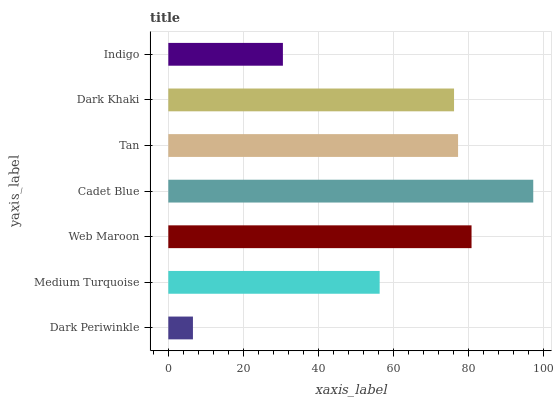Is Dark Periwinkle the minimum?
Answer yes or no. Yes. Is Cadet Blue the maximum?
Answer yes or no. Yes. Is Medium Turquoise the minimum?
Answer yes or no. No. Is Medium Turquoise the maximum?
Answer yes or no. No. Is Medium Turquoise greater than Dark Periwinkle?
Answer yes or no. Yes. Is Dark Periwinkle less than Medium Turquoise?
Answer yes or no. Yes. Is Dark Periwinkle greater than Medium Turquoise?
Answer yes or no. No. Is Medium Turquoise less than Dark Periwinkle?
Answer yes or no. No. Is Dark Khaki the high median?
Answer yes or no. Yes. Is Dark Khaki the low median?
Answer yes or no. Yes. Is Indigo the high median?
Answer yes or no. No. Is Tan the low median?
Answer yes or no. No. 